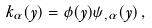Convert formula to latex. <formula><loc_0><loc_0><loc_500><loc_500>k _ { \alpha } ( y ) = \phi ( y ) \psi _ { , \alpha } ( y ) \, ,</formula> 